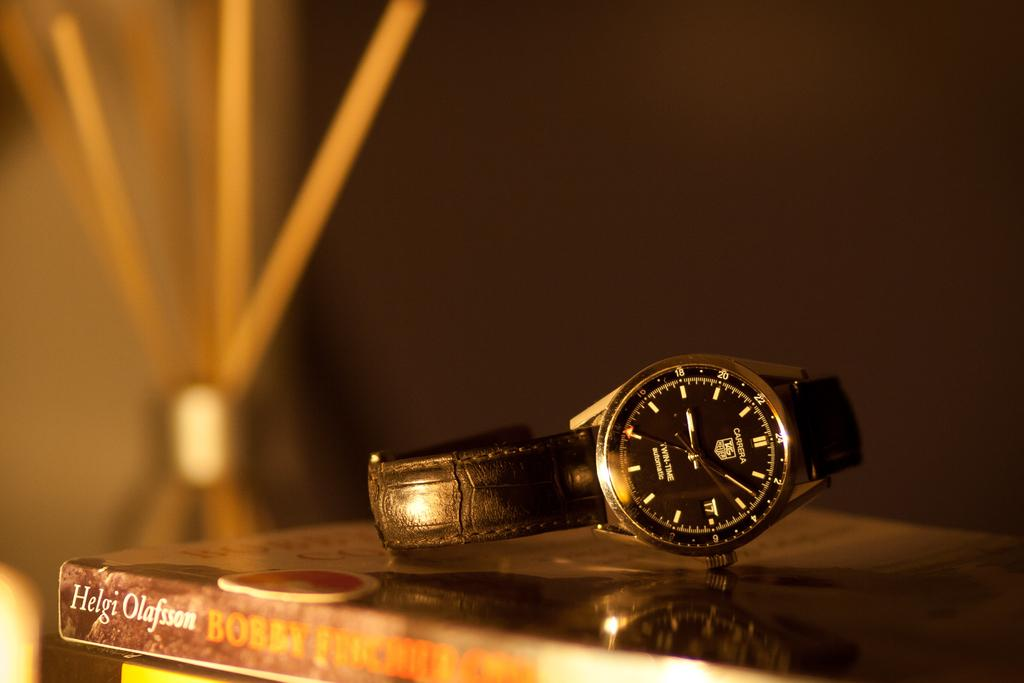<image>
Present a compact description of the photo's key features. A black Carrera watch is on top of a book. 